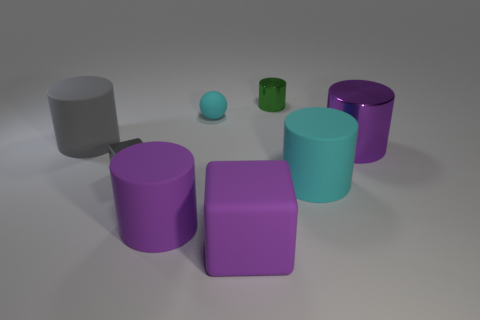What is the material of the large cylinder that is the same color as the tiny block?
Make the answer very short. Rubber. What number of objects are big gray rubber cylinders or cyan matte balls?
Make the answer very short. 2. Are the cylinder on the left side of the metallic block and the tiny cyan object made of the same material?
Keep it short and to the point. Yes. What number of objects are either metallic cubes on the left side of the tiny cyan matte sphere or big matte cylinders?
Your answer should be compact. 4. What is the color of the tiny thing that is the same material as the large cyan object?
Give a very brief answer. Cyan. Are there any green shiny things that have the same size as the gray metal cube?
Your response must be concise. Yes. There is a big rubber thing right of the big block; does it have the same color as the large metal cylinder?
Your answer should be very brief. No. What color is the metallic thing that is on the right side of the rubber block and in front of the big gray cylinder?
Your answer should be very brief. Purple. There is a gray object that is the same size as the green metal cylinder; what shape is it?
Make the answer very short. Cube. Are there any large things of the same shape as the tiny cyan object?
Keep it short and to the point. No. 